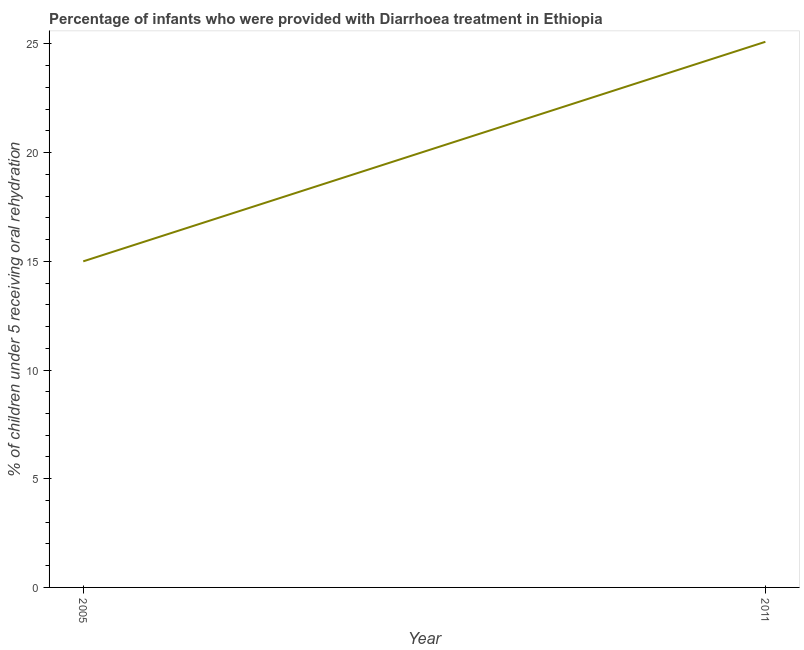What is the percentage of children who were provided with treatment diarrhoea in 2011?
Offer a very short reply. 25.1. Across all years, what is the maximum percentage of children who were provided with treatment diarrhoea?
Make the answer very short. 25.1. Across all years, what is the minimum percentage of children who were provided with treatment diarrhoea?
Offer a very short reply. 15. In which year was the percentage of children who were provided with treatment diarrhoea minimum?
Offer a very short reply. 2005. What is the sum of the percentage of children who were provided with treatment diarrhoea?
Provide a succinct answer. 40.1. What is the difference between the percentage of children who were provided with treatment diarrhoea in 2005 and 2011?
Your response must be concise. -10.1. What is the average percentage of children who were provided with treatment diarrhoea per year?
Keep it short and to the point. 20.05. What is the median percentage of children who were provided with treatment diarrhoea?
Keep it short and to the point. 20.05. What is the ratio of the percentage of children who were provided with treatment diarrhoea in 2005 to that in 2011?
Provide a succinct answer. 0.6. In how many years, is the percentage of children who were provided with treatment diarrhoea greater than the average percentage of children who were provided with treatment diarrhoea taken over all years?
Provide a succinct answer. 1. Does the percentage of children who were provided with treatment diarrhoea monotonically increase over the years?
Provide a succinct answer. Yes. Are the values on the major ticks of Y-axis written in scientific E-notation?
Your answer should be very brief. No. Does the graph contain any zero values?
Your answer should be very brief. No. Does the graph contain grids?
Give a very brief answer. No. What is the title of the graph?
Offer a very short reply. Percentage of infants who were provided with Diarrhoea treatment in Ethiopia. What is the label or title of the X-axis?
Provide a succinct answer. Year. What is the label or title of the Y-axis?
Offer a very short reply. % of children under 5 receiving oral rehydration. What is the % of children under 5 receiving oral rehydration of 2005?
Ensure brevity in your answer.  15. What is the % of children under 5 receiving oral rehydration of 2011?
Offer a very short reply. 25.1. What is the ratio of the % of children under 5 receiving oral rehydration in 2005 to that in 2011?
Keep it short and to the point. 0.6. 